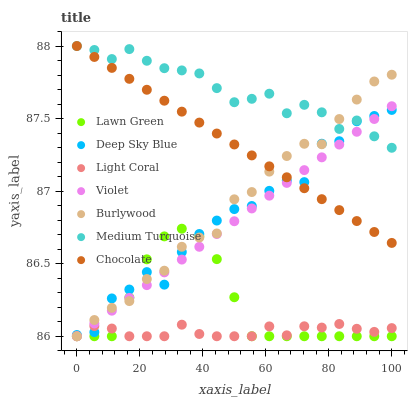Does Light Coral have the minimum area under the curve?
Answer yes or no. Yes. Does Medium Turquoise have the maximum area under the curve?
Answer yes or no. Yes. Does Deep Sky Blue have the minimum area under the curve?
Answer yes or no. No. Does Deep Sky Blue have the maximum area under the curve?
Answer yes or no. No. Is Violet the smoothest?
Answer yes or no. Yes. Is Deep Sky Blue the roughest?
Answer yes or no. Yes. Is Burlywood the smoothest?
Answer yes or no. No. Is Burlywood the roughest?
Answer yes or no. No. Does Lawn Green have the lowest value?
Answer yes or no. Yes. Does Deep Sky Blue have the lowest value?
Answer yes or no. No. Does Medium Turquoise have the highest value?
Answer yes or no. Yes. Does Deep Sky Blue have the highest value?
Answer yes or no. No. Is Lawn Green less than Chocolate?
Answer yes or no. Yes. Is Medium Turquoise greater than Lawn Green?
Answer yes or no. Yes. Does Medium Turquoise intersect Burlywood?
Answer yes or no. Yes. Is Medium Turquoise less than Burlywood?
Answer yes or no. No. Is Medium Turquoise greater than Burlywood?
Answer yes or no. No. Does Lawn Green intersect Chocolate?
Answer yes or no. No. 